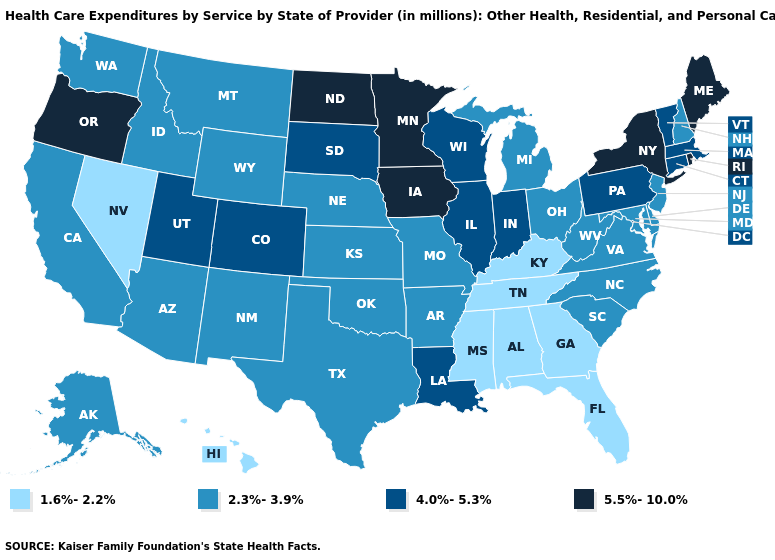Name the states that have a value in the range 4.0%-5.3%?
Short answer required. Colorado, Connecticut, Illinois, Indiana, Louisiana, Massachusetts, Pennsylvania, South Dakota, Utah, Vermont, Wisconsin. Which states hav the highest value in the MidWest?
Write a very short answer. Iowa, Minnesota, North Dakota. What is the highest value in the West ?
Quick response, please. 5.5%-10.0%. Among the states that border Rhode Island , which have the highest value?
Quick response, please. Connecticut, Massachusetts. Does Vermont have a lower value than New York?
Be succinct. Yes. Name the states that have a value in the range 1.6%-2.2%?
Answer briefly. Alabama, Florida, Georgia, Hawaii, Kentucky, Mississippi, Nevada, Tennessee. Which states have the lowest value in the USA?
Be succinct. Alabama, Florida, Georgia, Hawaii, Kentucky, Mississippi, Nevada, Tennessee. Does Maine have the lowest value in the Northeast?
Quick response, please. No. Name the states that have a value in the range 2.3%-3.9%?
Keep it brief. Alaska, Arizona, Arkansas, California, Delaware, Idaho, Kansas, Maryland, Michigan, Missouri, Montana, Nebraska, New Hampshire, New Jersey, New Mexico, North Carolina, Ohio, Oklahoma, South Carolina, Texas, Virginia, Washington, West Virginia, Wyoming. What is the value of Kansas?
Quick response, please. 2.3%-3.9%. Does Idaho have a higher value than Florida?
Quick response, please. Yes. What is the value of Connecticut?
Short answer required. 4.0%-5.3%. Is the legend a continuous bar?
Short answer required. No. How many symbols are there in the legend?
Keep it brief. 4. What is the highest value in states that border West Virginia?
Short answer required. 4.0%-5.3%. 